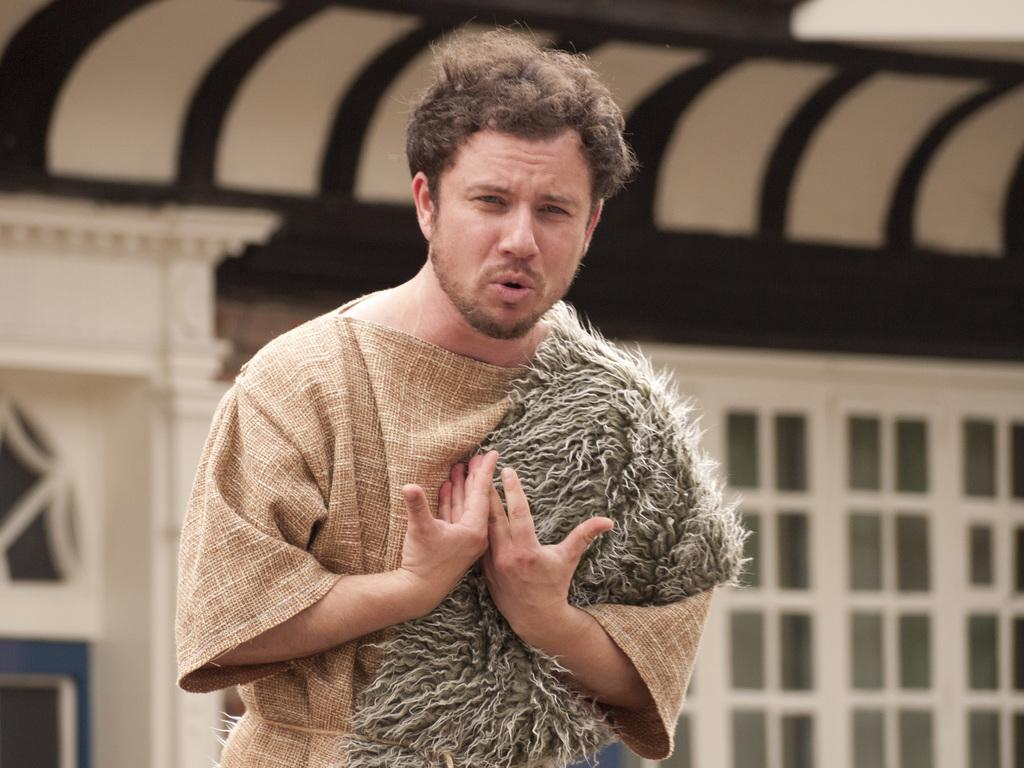What is the main subject of the image? There is a person in the image. Can you describe the background of the image? The background of the image is blurred. What can be observed about the person's attire in the image? The person in the image is wearing clothes. What type of show is the person in the image performing? There is no indication in the image that the person is performing a show. Can you tell me how many friends are visible with the person in the image? There is no reference to friends in the image, as it only features a single person. --- 